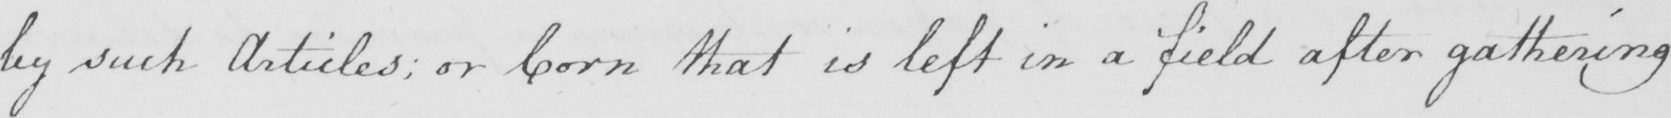Transcribe the text shown in this historical manuscript line. by such Articles ; or Corn that is left in a field after gathering 